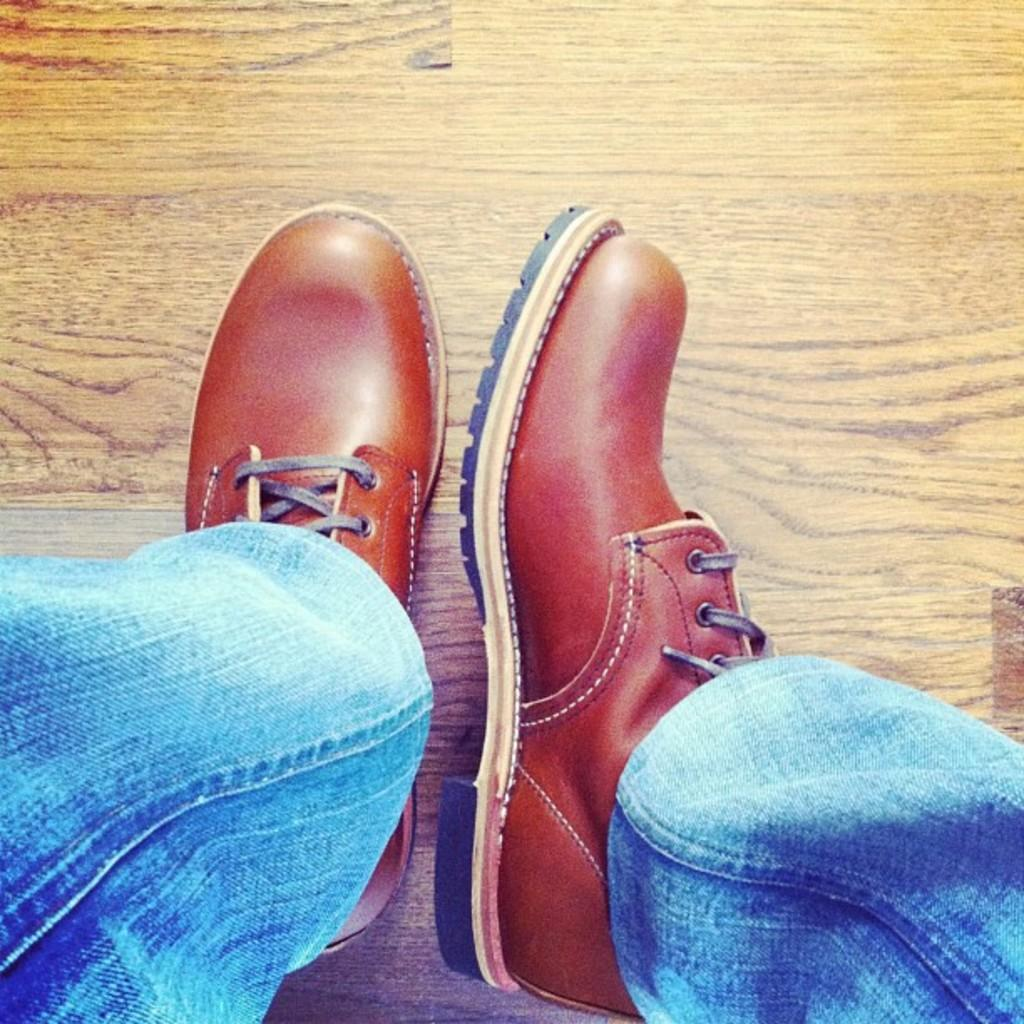How many giants can be seen interacting with the ground and the creature in the image? There is no image provided, so it is impossible to determine the presence or actions of giants, the ground, or any creatures. 